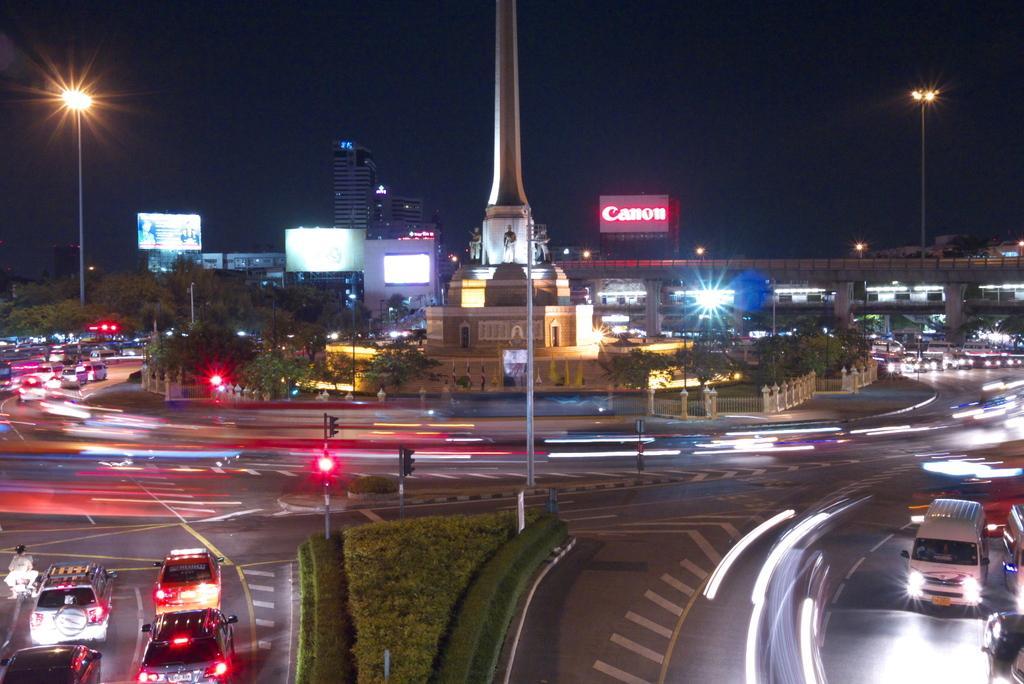In one or two sentences, can you explain what this image depicts? This image is taken outdoors. At the top of the image there is the sky. At the bottom of the image there is a road and there is a ground with grass on it. There are many plants on the ground. In the middle of the image many vehicles are moving on the roads. There are a few poles with signal lights and street lights. There are many trees. There are a few buildings and there is an architecture. There is a railing and there is a bridge with walls and pillars. There are a few boards with text on them. 